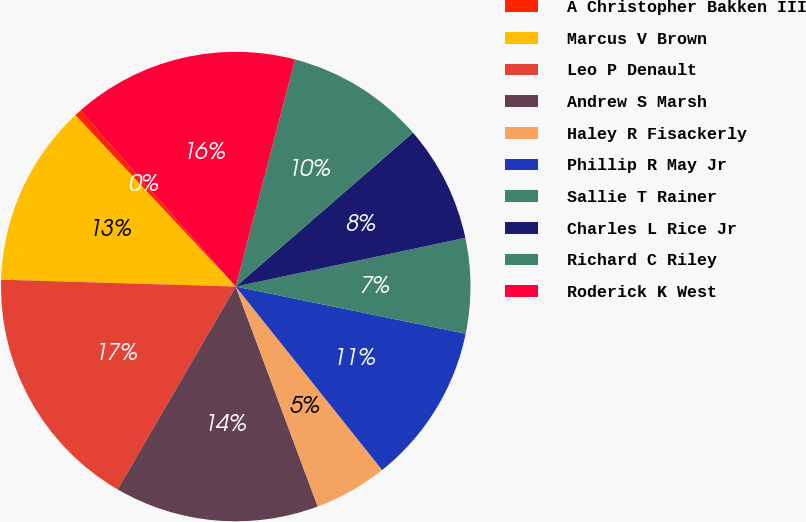<chart> <loc_0><loc_0><loc_500><loc_500><pie_chart><fcel>A Christopher Bakken III<fcel>Marcus V Brown<fcel>Leo P Denault<fcel>Andrew S Marsh<fcel>Haley R Fisackerly<fcel>Phillip R May Jr<fcel>Sallie T Rainer<fcel>Charles L Rice Jr<fcel>Richard C Riley<fcel>Roderick K West<nl><fcel>0.47%<fcel>12.56%<fcel>17.08%<fcel>14.07%<fcel>5.04%<fcel>11.06%<fcel>6.55%<fcel>8.05%<fcel>9.56%<fcel>15.57%<nl></chart> 